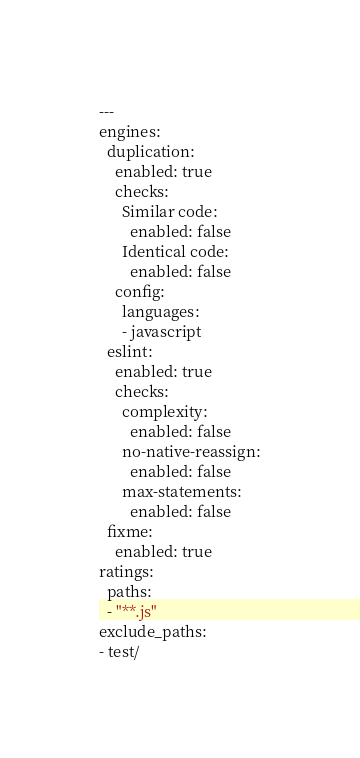Convert code to text. <code><loc_0><loc_0><loc_500><loc_500><_YAML_>---
engines:
  duplication:
    enabled: true
    checks:
      Similar code:
        enabled: false
      Identical code:
        enabled: false
    config:
      languages:
      - javascript
  eslint:
    enabled: true
    checks:
      complexity:
        enabled: false
      no-native-reassign:
        enabled: false
      max-statements:
        enabled: false
  fixme:
    enabled: true
ratings:
  paths:
  - "**.js"
exclude_paths:
- test/
</code> 